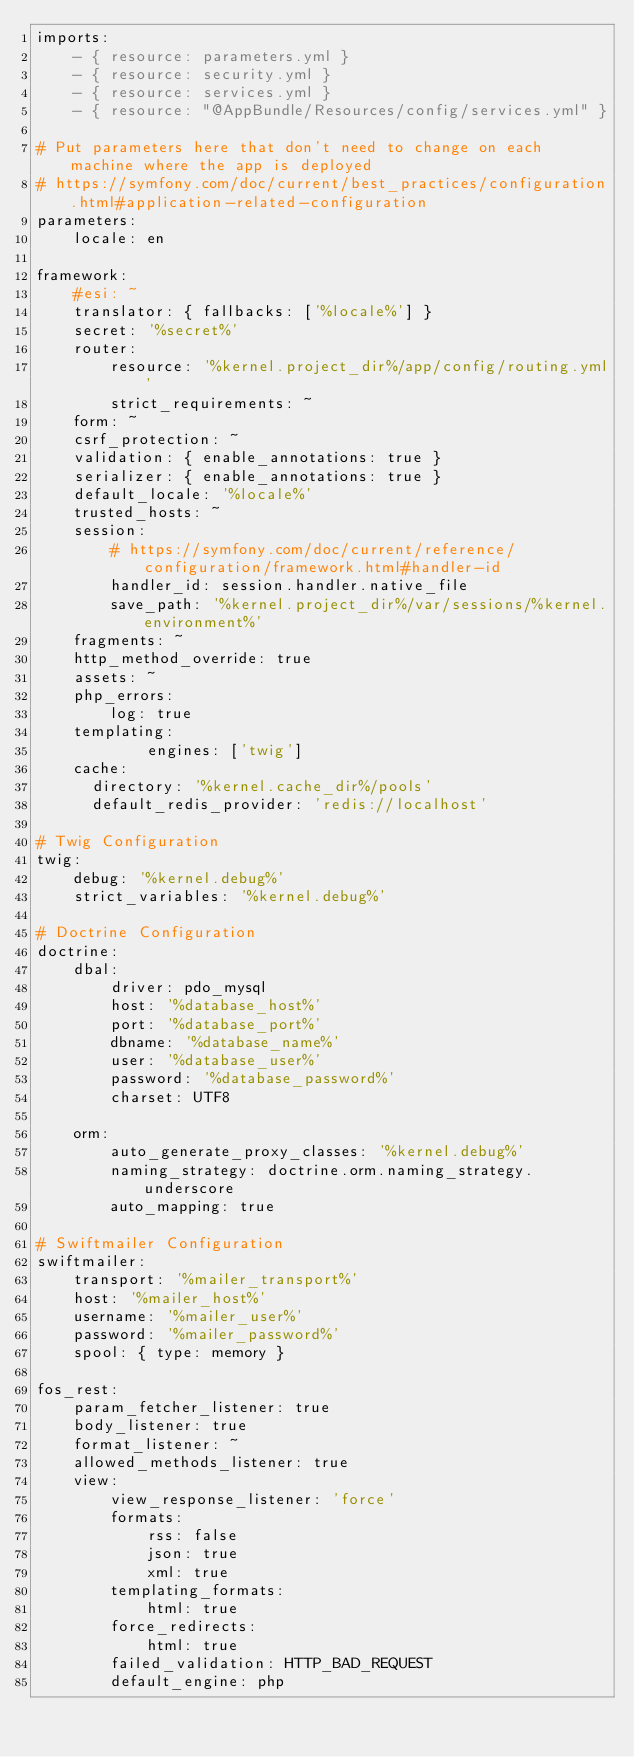<code> <loc_0><loc_0><loc_500><loc_500><_YAML_>imports:
    - { resource: parameters.yml }
    - { resource: security.yml }
    - { resource: services.yml }
    - { resource: "@AppBundle/Resources/config/services.yml" }

# Put parameters here that don't need to change on each machine where the app is deployed
# https://symfony.com/doc/current/best_practices/configuration.html#application-related-configuration
parameters:
    locale: en

framework:
    #esi: ~
    translator: { fallbacks: ['%locale%'] }
    secret: '%secret%'
    router:
        resource: '%kernel.project_dir%/app/config/routing.yml'
        strict_requirements: ~
    form: ~
    csrf_protection: ~
    validation: { enable_annotations: true }
    serializer: { enable_annotations: true }
    default_locale: '%locale%'
    trusted_hosts: ~
    session:
        # https://symfony.com/doc/current/reference/configuration/framework.html#handler-id
        handler_id: session.handler.native_file
        save_path: '%kernel.project_dir%/var/sessions/%kernel.environment%'
    fragments: ~
    http_method_override: true
    assets: ~
    php_errors:
        log: true
    templating:
            engines: ['twig']
    cache:
      directory: '%kernel.cache_dir%/pools'
      default_redis_provider: 'redis://localhost'

# Twig Configuration
twig:
    debug: '%kernel.debug%'
    strict_variables: '%kernel.debug%'

# Doctrine Configuration
doctrine:
    dbal:
        driver: pdo_mysql
        host: '%database_host%'
        port: '%database_port%'
        dbname: '%database_name%'
        user: '%database_user%'
        password: '%database_password%'
        charset: UTF8

    orm:
        auto_generate_proxy_classes: '%kernel.debug%'
        naming_strategy: doctrine.orm.naming_strategy.underscore
        auto_mapping: true

# Swiftmailer Configuration
swiftmailer:
    transport: '%mailer_transport%'
    host: '%mailer_host%'
    username: '%mailer_user%'
    password: '%mailer_password%'
    spool: { type: memory }

fos_rest:
    param_fetcher_listener: true
    body_listener: true
    format_listener: ~
    allowed_methods_listener: true
    view:
        view_response_listener: 'force'
        formats:
            rss: false
            json: true
            xml: true
        templating_formats:
            html: true
        force_redirects:
            html: true
        failed_validation: HTTP_BAD_REQUEST
        default_engine: php</code> 